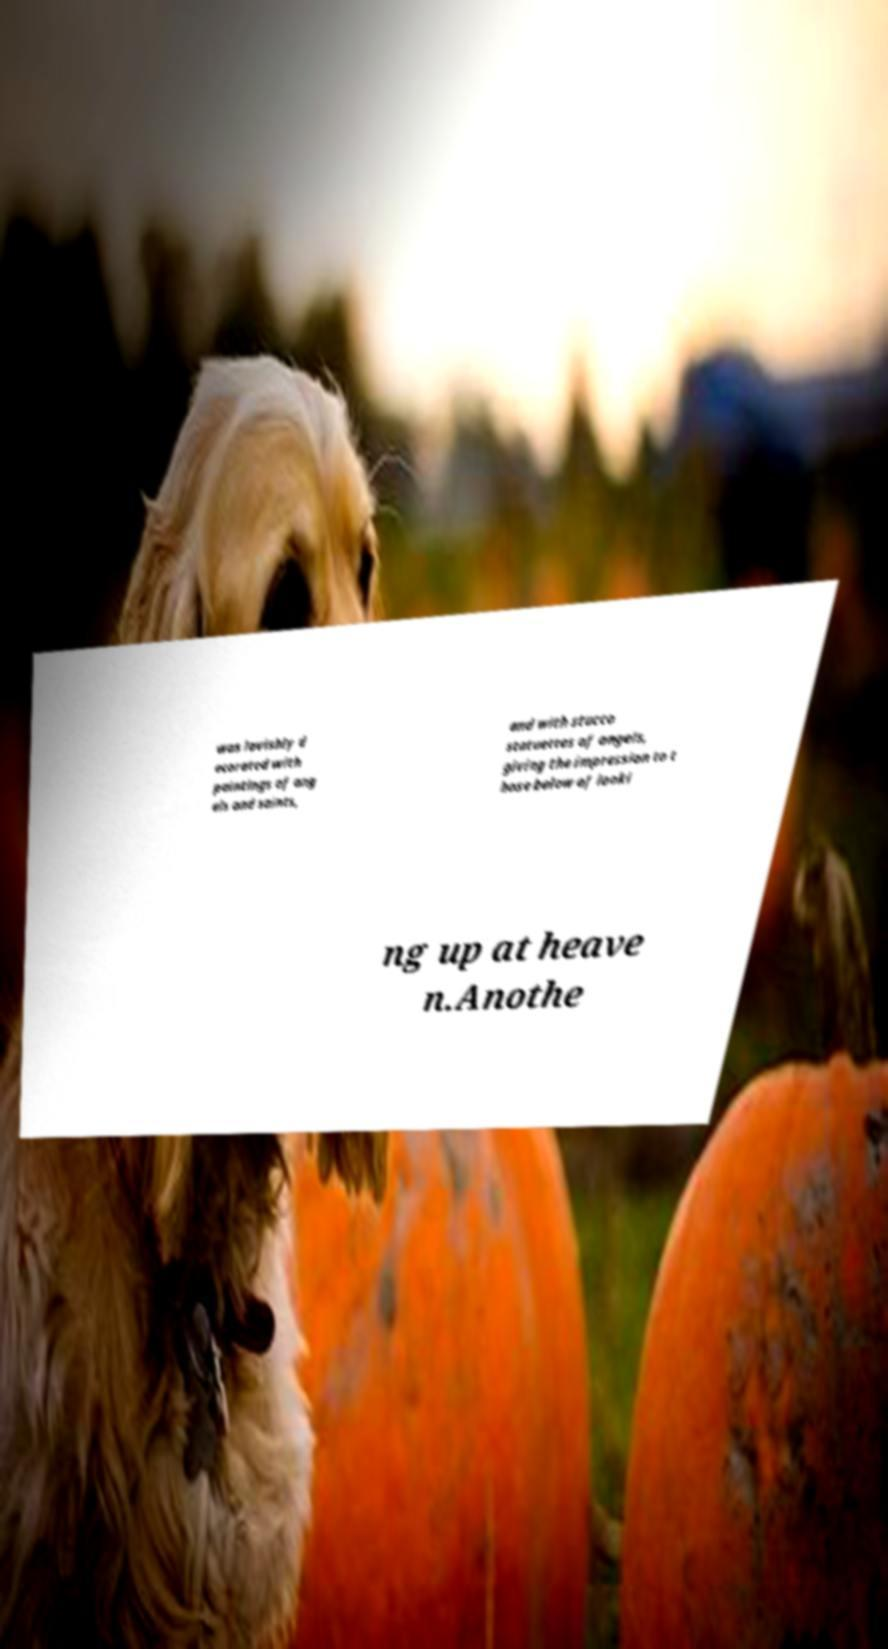Please read and relay the text visible in this image. What does it say? was lavishly d ecorated with paintings of ang els and saints, and with stucco statuettes of angels, giving the impression to t hose below of looki ng up at heave n.Anothe 